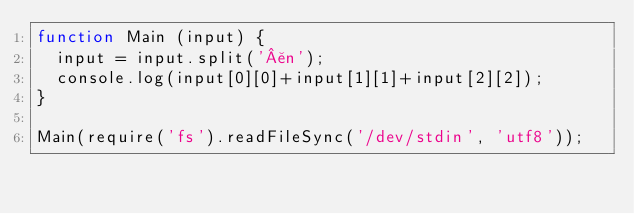<code> <loc_0><loc_0><loc_500><loc_500><_JavaScript_>function Main (input) {
  input = input.split('¥n');
  console.log(input[0][0]+input[1][1]+input[2][2]);
}

Main(require('fs').readFileSync('/dev/stdin', 'utf8'));
</code> 